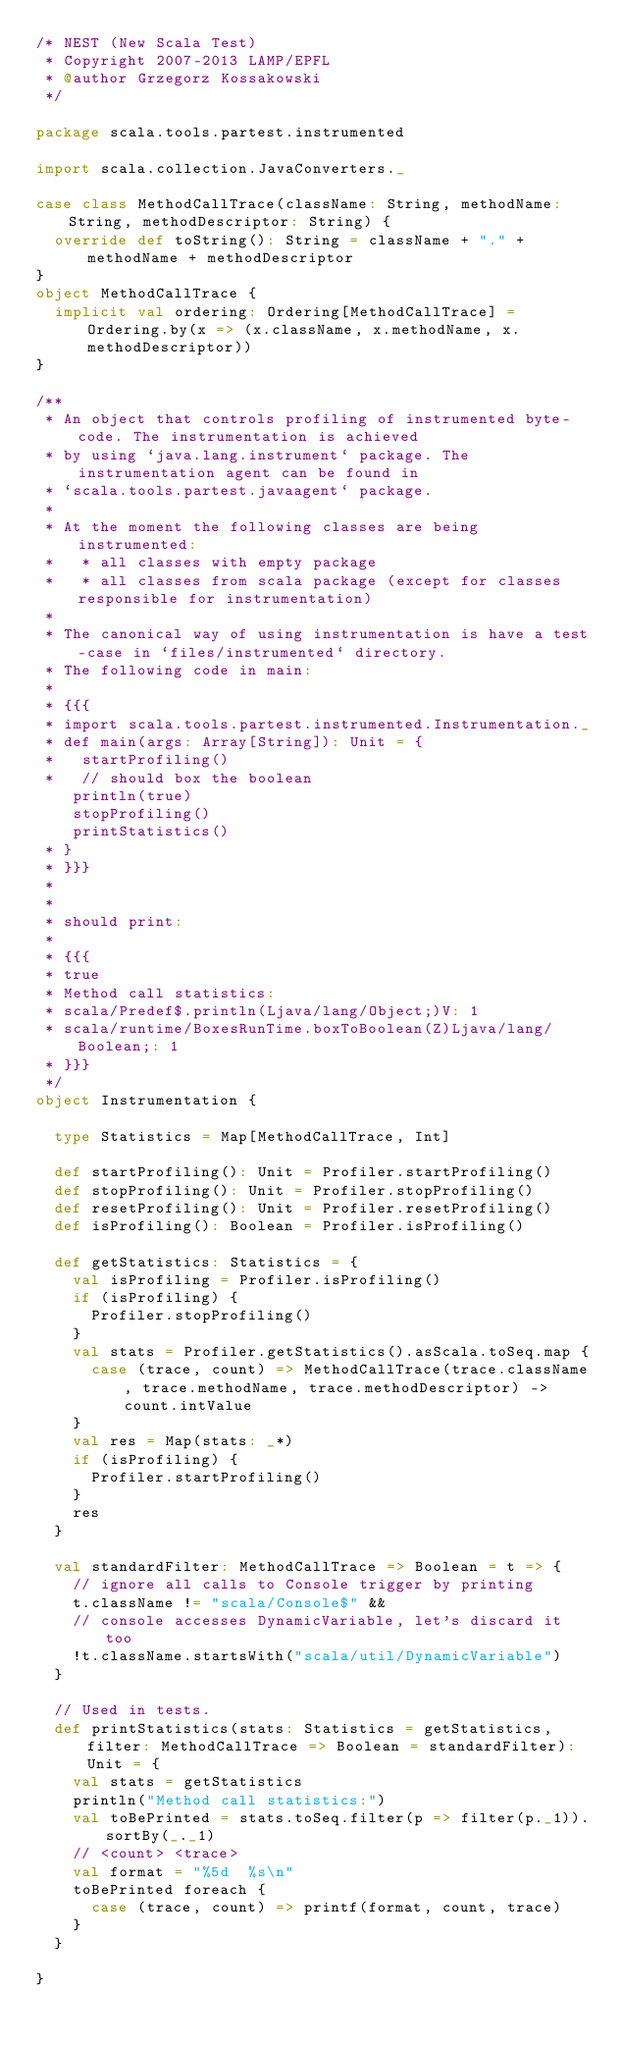<code> <loc_0><loc_0><loc_500><loc_500><_Scala_>/* NEST (New Scala Test)
 * Copyright 2007-2013 LAMP/EPFL
 * @author Grzegorz Kossakowski
 */

package scala.tools.partest.instrumented

import scala.collection.JavaConverters._

case class MethodCallTrace(className: String, methodName: String, methodDescriptor: String) {
  override def toString(): String = className + "." + methodName + methodDescriptor
}
object MethodCallTrace {
  implicit val ordering: Ordering[MethodCallTrace] = Ordering.by(x => (x.className, x.methodName, x.methodDescriptor))
}

/**
 * An object that controls profiling of instrumented byte-code. The instrumentation is achieved
 * by using `java.lang.instrument` package. The instrumentation agent can be found in
 * `scala.tools.partest.javaagent` package.
 *
 * At the moment the following classes are being instrumented:
 *   * all classes with empty package
 *   * all classes from scala package (except for classes responsible for instrumentation)
 *
 * The canonical way of using instrumentation is have a test-case in `files/instrumented` directory.
 * The following code in main:
 *
 * {{{
 * import scala.tools.partest.instrumented.Instrumentation._
 * def main(args: Array[String]): Unit = {
 *   startProfiling()
 *   // should box the boolean
    println(true)
    stopProfiling()
    printStatistics()
 * }
 * }}}
 *
 *
 * should print:
 *
 * {{{
 * true
 * Method call statistics:
 * scala/Predef$.println(Ljava/lang/Object;)V: 1
 * scala/runtime/BoxesRunTime.boxToBoolean(Z)Ljava/lang/Boolean;: 1
 * }}}
 */
object Instrumentation {

  type Statistics = Map[MethodCallTrace, Int]

  def startProfiling(): Unit = Profiler.startProfiling()
  def stopProfiling(): Unit = Profiler.stopProfiling()
  def resetProfiling(): Unit = Profiler.resetProfiling()
  def isProfiling(): Boolean = Profiler.isProfiling()

  def getStatistics: Statistics = {
    val isProfiling = Profiler.isProfiling()
    if (isProfiling) {
      Profiler.stopProfiling()
    }
    val stats = Profiler.getStatistics().asScala.toSeq.map {
      case (trace, count) => MethodCallTrace(trace.className, trace.methodName, trace.methodDescriptor) -> count.intValue
    }
    val res = Map(stats: _*)
    if (isProfiling) {
      Profiler.startProfiling()
    }
    res
  }

  val standardFilter: MethodCallTrace => Boolean = t => {
    // ignore all calls to Console trigger by printing
    t.className != "scala/Console$" &&
    // console accesses DynamicVariable, let's discard it too
    !t.className.startsWith("scala/util/DynamicVariable")
  }

  // Used in tests.
  def printStatistics(stats: Statistics = getStatistics, filter: MethodCallTrace => Boolean = standardFilter): Unit = {
    val stats = getStatistics
    println("Method call statistics:")
    val toBePrinted = stats.toSeq.filter(p => filter(p._1)).sortBy(_._1)
    // <count> <trace>
    val format = "%5d  %s\n"
    toBePrinted foreach {
      case (trace, count) => printf(format, count, trace)
    }
  }

}
</code> 